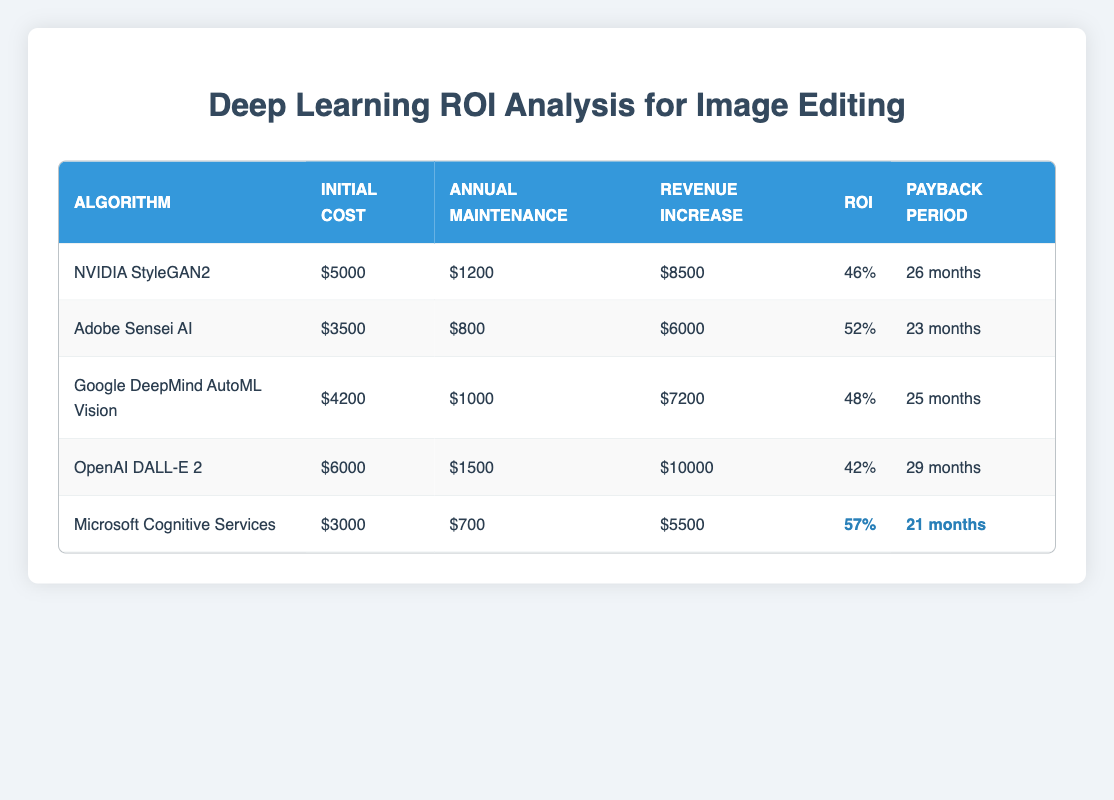What is the initial cost of Adobe Sensei AI? The initial cost of Adobe Sensei AI is directly listed in the table under the "Initial Cost" column. It shows a value of 3500.
Answer: 3500 Which algorithm has the highest revenue increase? By comparing the "Revenue Increase" values for each algorithm, OpenAI DALL-E 2 has the highest value listed as 10000.
Answer: 10000 What is the payback period for Microsoft Cognitive Services? The payback period for Microsoft Cognitive Services is provided in the table under the "Payback Period" column, showing a value of 21 months.
Answer: 21 months What is the average ROI percentage of all algorithms? To find the average ROI percentage, sum the ROI values (46 + 52 + 48 + 42 + 57 = 245) and divide by the number of algorithms (5). Thus, 245/5 = 49.
Answer: 49 Is the ROI percentage of NVIDIA StyleGAN2 higher than that of OpenAI DALL-E 2? Comparing the ROI percentage values, NVIDIA StyleGAN2 has a percentage of 46 while OpenAI DALL-E 2 has a percentage of 42. Since 46 is greater than 42, the statement is true.
Answer: Yes Which algorithm has the lowest annual maintenance cost? By examining the "Annual Maintenance" values for each algorithm, Microsoft Cognitive Services shows the lowest maintenance cost of 700.
Answer: 700 If you rank the algorithms by ROI, what is the ROI of the second highest algorithm? The algorithms ranked by ROI show Microsoft Cognitive Services as the highest (57), followed by Adobe Sensei AI (52). Thus, the ROI for the second highest algorithm is 52.
Answer: 52 What is the total initial cost of all algorithms combined? The total initial cost can be found by summing all the initial costs: 5000 + 3500 + 4200 + 6000 + 3000 = 21700.
Answer: 21700 